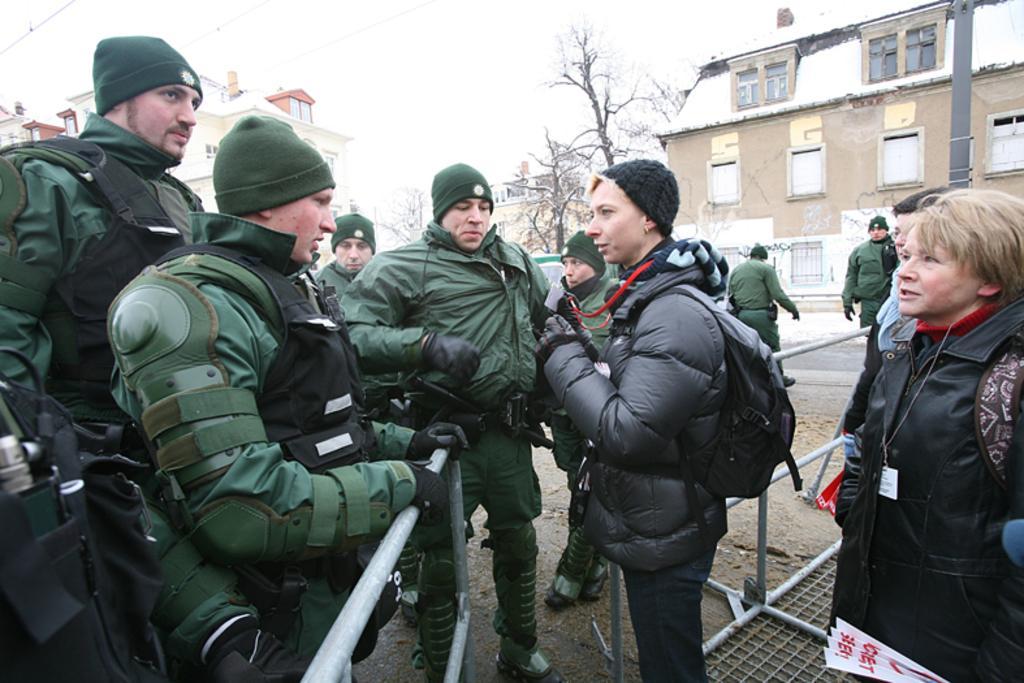Please provide a concise description of this image. In this image we can see these people wearing green color dresses and caps are standing here and these two women wearing black jackets are standing here. In the background, we can see the houses, trees and the sky. 